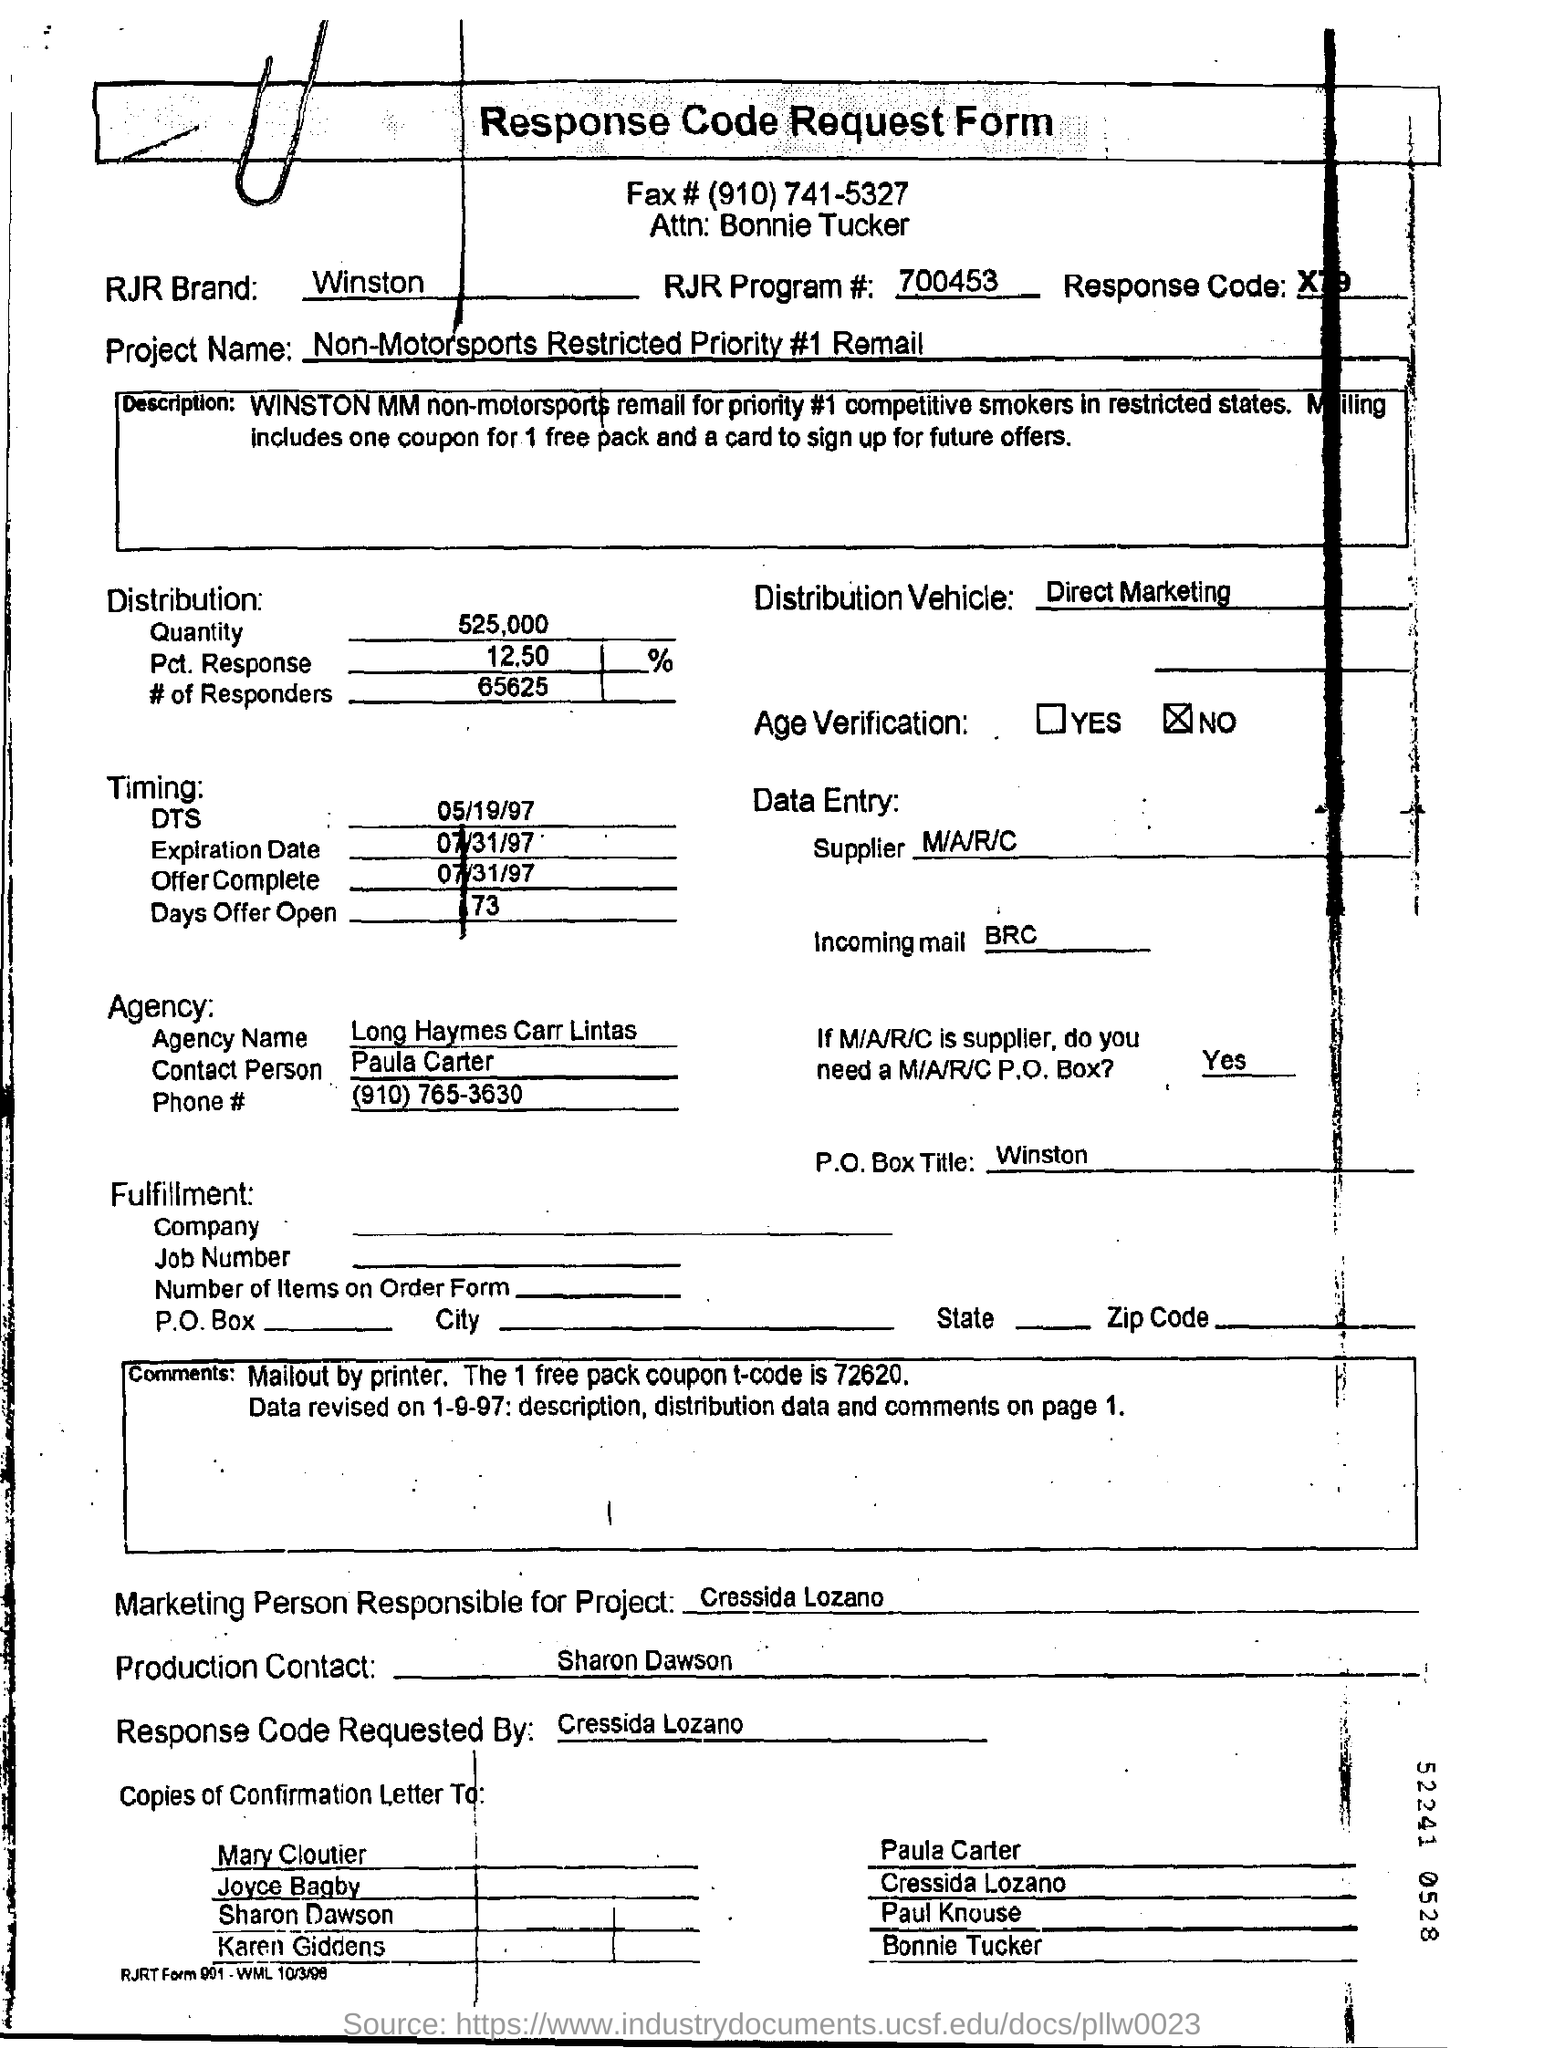What is the Fax Number ?
Give a very brief answer. (910) 741-5327. What is the RJR Brand name ?
Your answer should be compact. Winston. What is the RJR Program Number ?
Offer a very short reply. 700453. Who is the Supplier ?
Provide a succinct answer. M/A/R/C. What is written in the Incoming Mail Field ?
Give a very brief answer. BRC. What is mentioned in the Production Contact Field ?
Provide a short and direct response. Sharon Dawson. What is the Expiration Date ?
Make the answer very short. 07/31/97. What is written in the P.O.Box Title Field ?
Your answer should be very brief. Winston. 